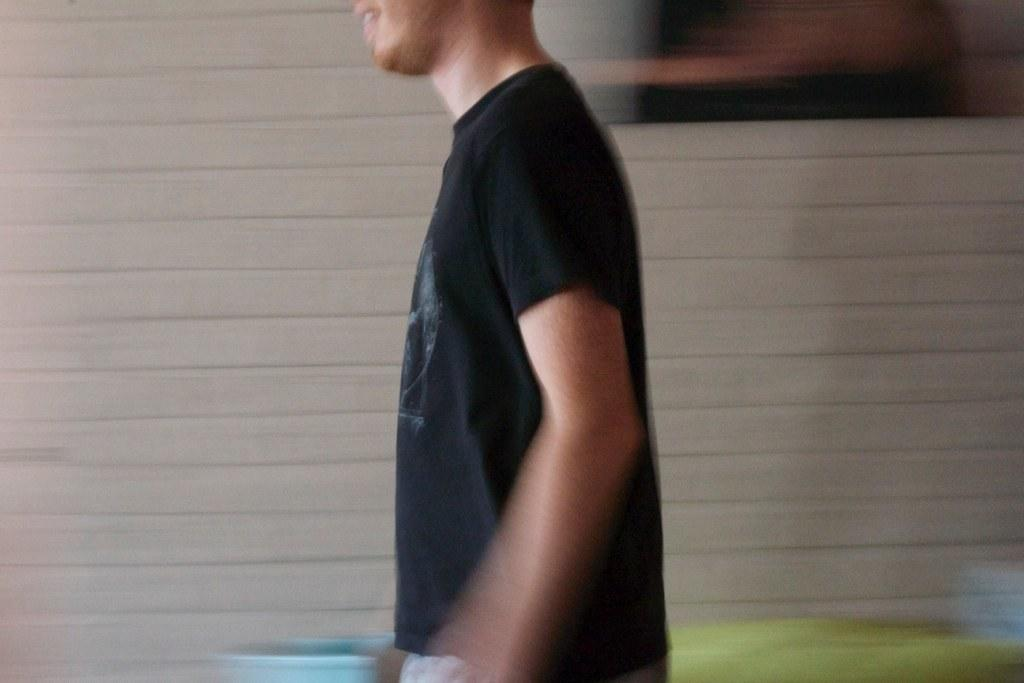Who is present in the image? There is a man in the image. What is the man wearing? The man is wearing a black t-shirt. What can be seen in the background of the image? There are objects visible at the back of the image. What is hanging on the wall in the image? There is a frame on the wall in the image. What type of ink is being used to write on the furniture in the image? There is no furniture or writing present in the image, so it is not possible to determine what type of ink might be used. 